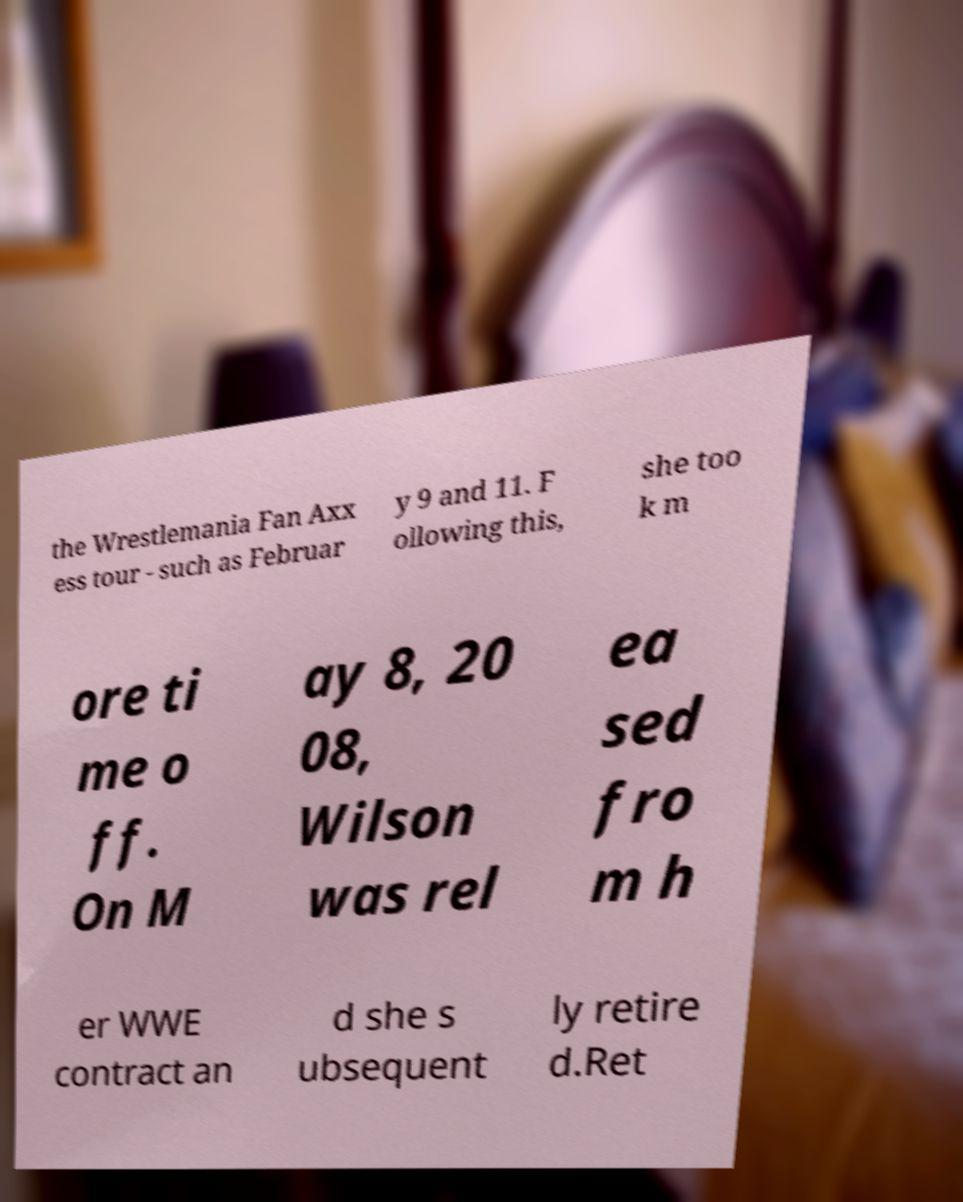Please read and relay the text visible in this image. What does it say? the Wrestlemania Fan Axx ess tour - such as Februar y 9 and 11. F ollowing this, she too k m ore ti me o ff. On M ay 8, 20 08, Wilson was rel ea sed fro m h er WWE contract an d she s ubsequent ly retire d.Ret 